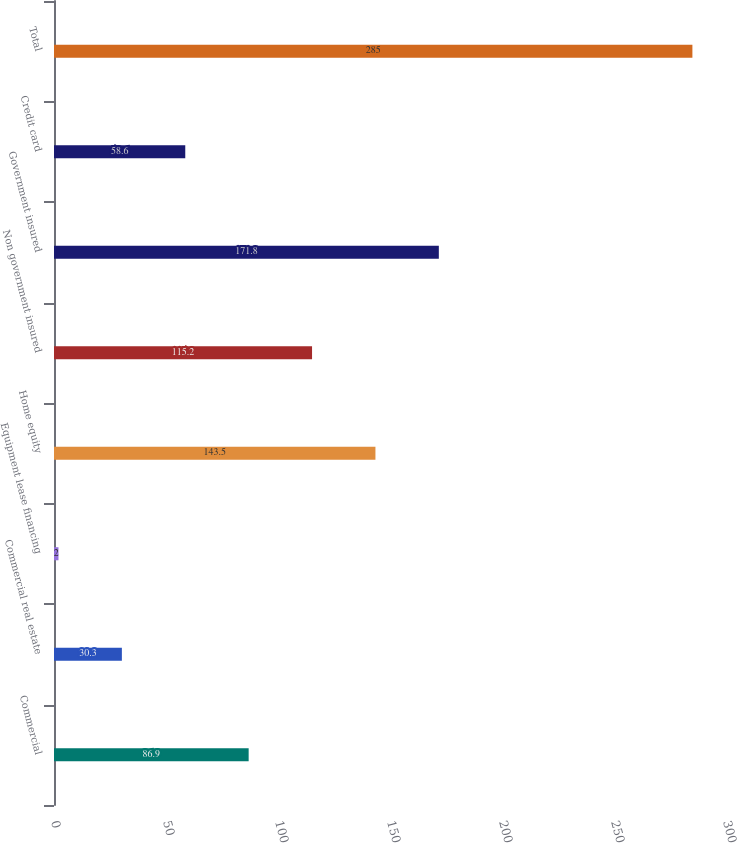<chart> <loc_0><loc_0><loc_500><loc_500><bar_chart><fcel>Commercial<fcel>Commercial real estate<fcel>Equipment lease financing<fcel>Home equity<fcel>Non government insured<fcel>Government insured<fcel>Credit card<fcel>Total<nl><fcel>86.9<fcel>30.3<fcel>2<fcel>143.5<fcel>115.2<fcel>171.8<fcel>58.6<fcel>285<nl></chart> 